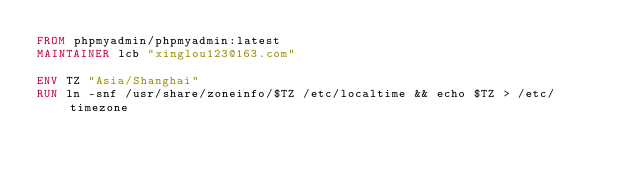Convert code to text. <code><loc_0><loc_0><loc_500><loc_500><_Dockerfile_>FROM phpmyadmin/phpmyadmin:latest
MAINTAINER lcb "xinglou123@163.com"

ENV TZ "Asia/Shanghai"
RUN ln -snf /usr/share/zoneinfo/$TZ /etc/localtime && echo $TZ > /etc/timezone</code> 